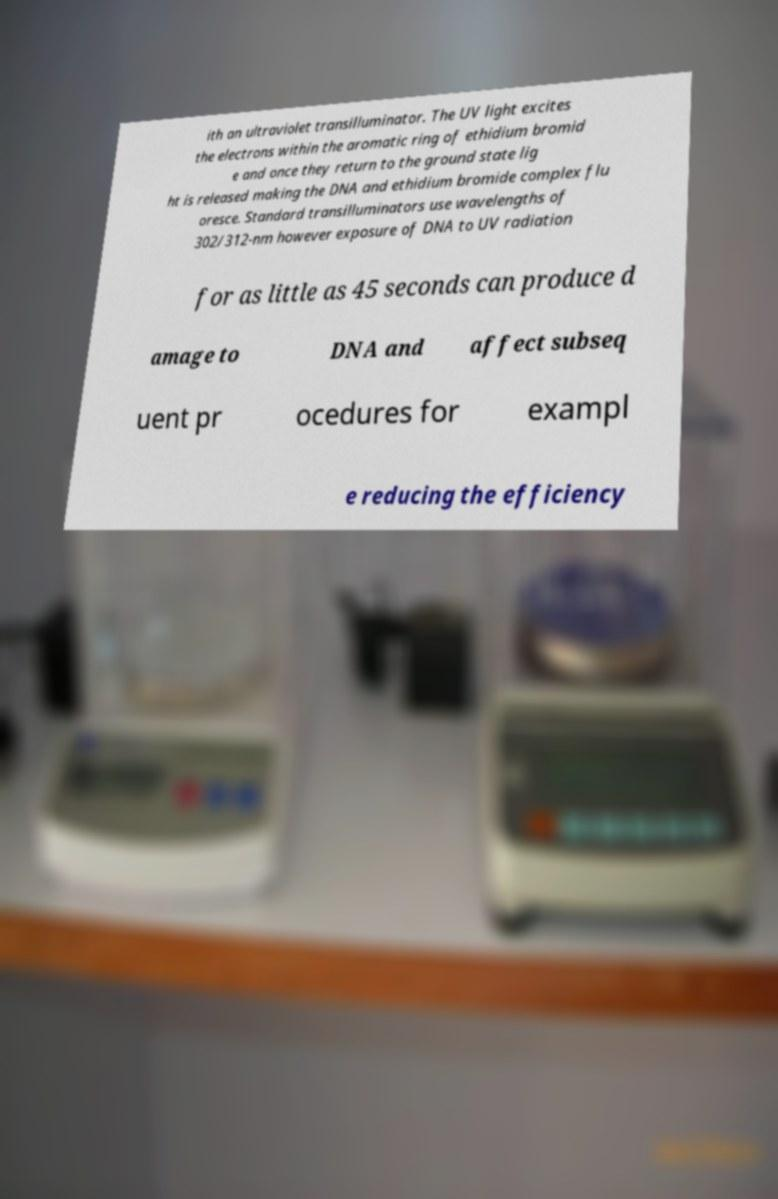Please identify and transcribe the text found in this image. ith an ultraviolet transilluminator. The UV light excites the electrons within the aromatic ring of ethidium bromid e and once they return to the ground state lig ht is released making the DNA and ethidium bromide complex flu oresce. Standard transilluminators use wavelengths of 302/312-nm however exposure of DNA to UV radiation for as little as 45 seconds can produce d amage to DNA and affect subseq uent pr ocedures for exampl e reducing the efficiency 